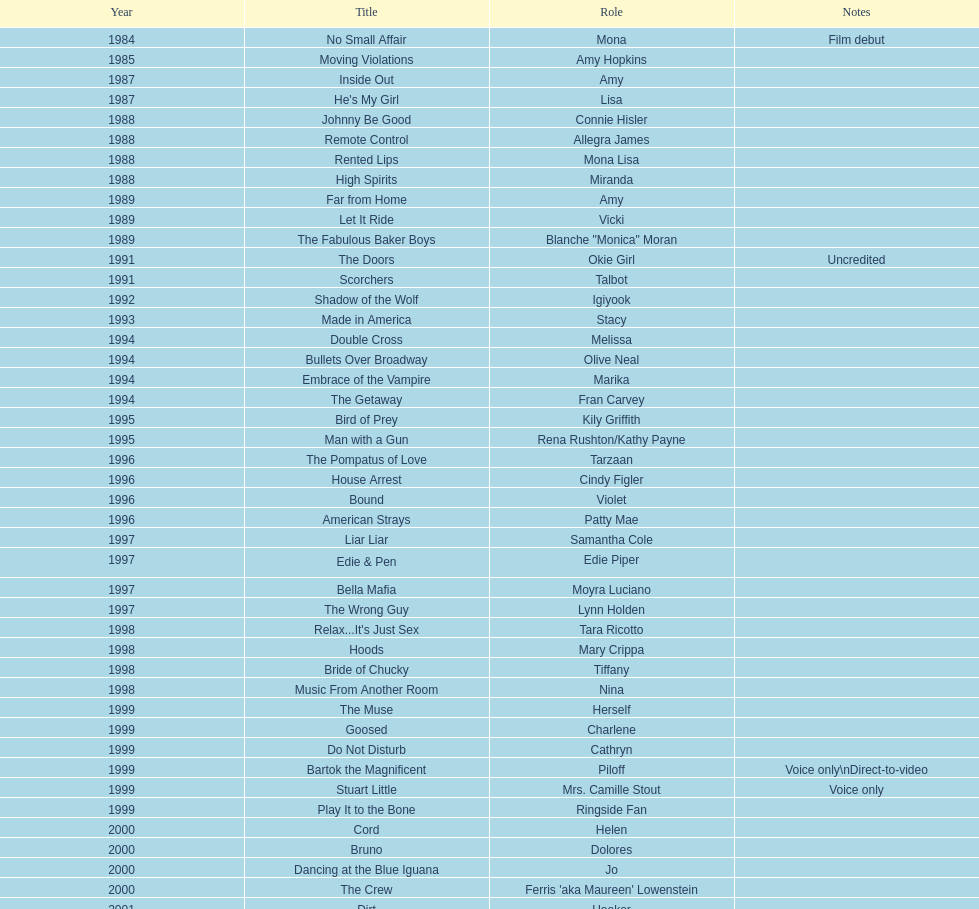Which film aired in 1994 and has marika as the role? Embrace of the Vampire. 